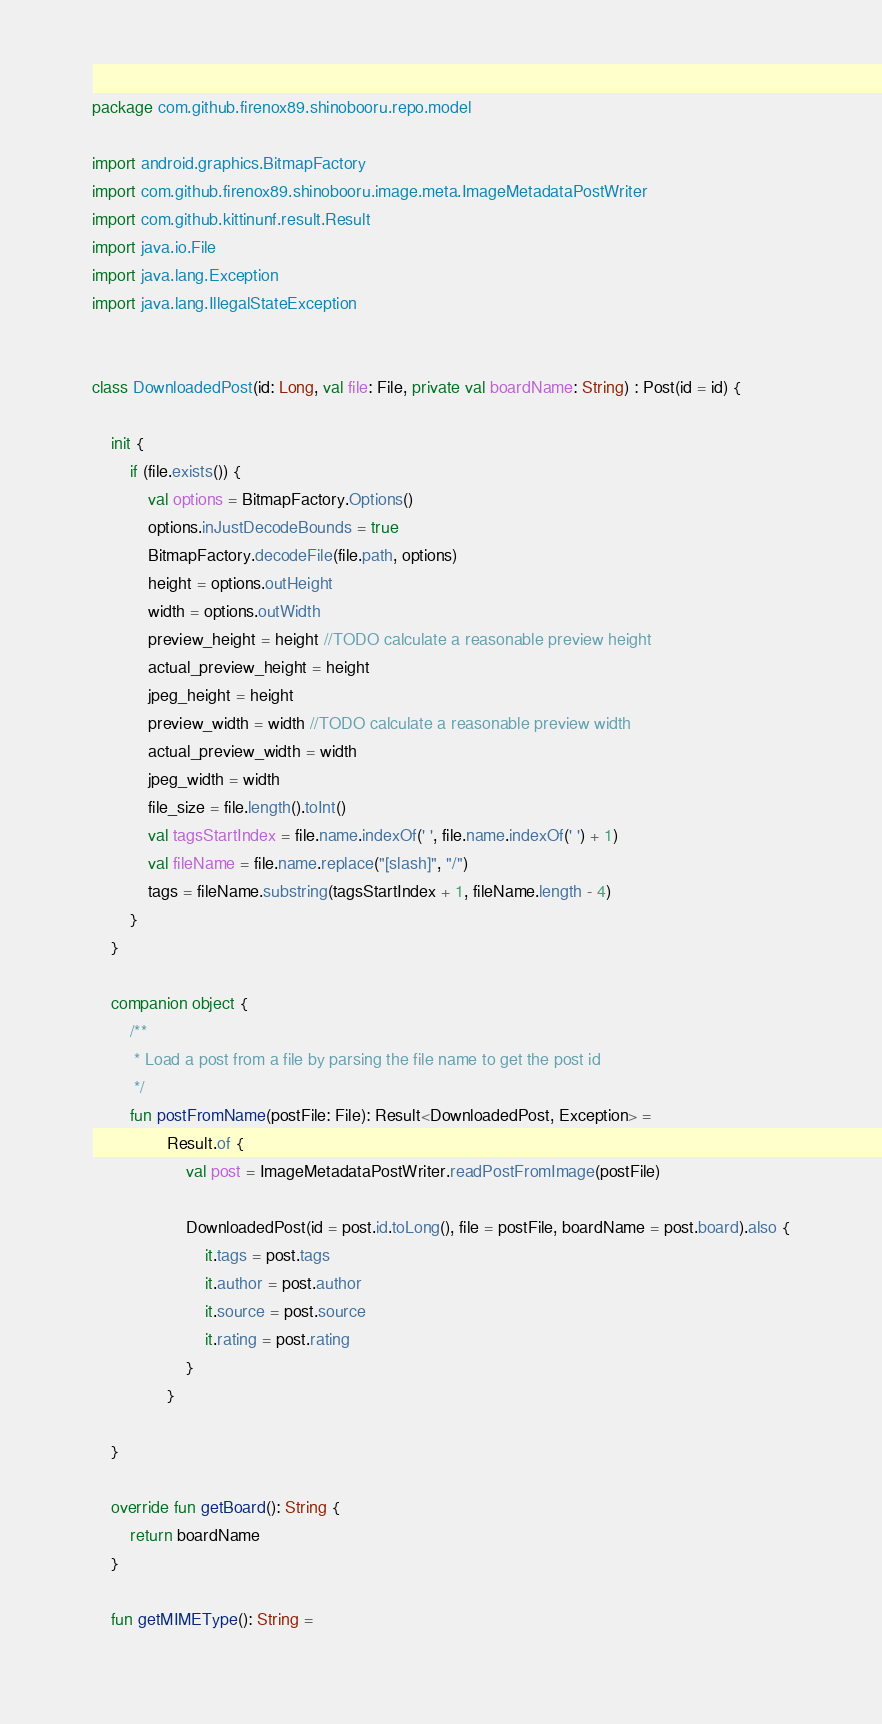Convert code to text. <code><loc_0><loc_0><loc_500><loc_500><_Kotlin_>package com.github.firenox89.shinobooru.repo.model

import android.graphics.BitmapFactory
import com.github.firenox89.shinobooru.image.meta.ImageMetadataPostWriter
import com.github.kittinunf.result.Result
import java.io.File
import java.lang.Exception
import java.lang.IllegalStateException


class DownloadedPost(id: Long, val file: File, private val boardName: String) : Post(id = id) {

    init {
        if (file.exists()) {
            val options = BitmapFactory.Options()
            options.inJustDecodeBounds = true
            BitmapFactory.decodeFile(file.path, options)
            height = options.outHeight
            width = options.outWidth
            preview_height = height //TODO calculate a reasonable preview height
            actual_preview_height = height
            jpeg_height = height
            preview_width = width //TODO calculate a reasonable preview width
            actual_preview_width = width
            jpeg_width = width
            file_size = file.length().toInt()
            val tagsStartIndex = file.name.indexOf(' ', file.name.indexOf(' ') + 1)
            val fileName = file.name.replace("[slash]", "/")
            tags = fileName.substring(tagsStartIndex + 1, fileName.length - 4)
        }
    }

    companion object {
        /**
         * Load a post from a file by parsing the file name to get the post id
         */
        fun postFromName(postFile: File): Result<DownloadedPost, Exception> =
                Result.of {
                    val post = ImageMetadataPostWriter.readPostFromImage(postFile)

                    DownloadedPost(id = post.id.toLong(), file = postFile, boardName = post.board).also {
                        it.tags = post.tags
                        it.author = post.author
                        it.source = post.source
                        it.rating = post.rating
                    }
                }

    }

    override fun getBoard(): String {
        return boardName
    }

    fun getMIMEType(): String =</code> 